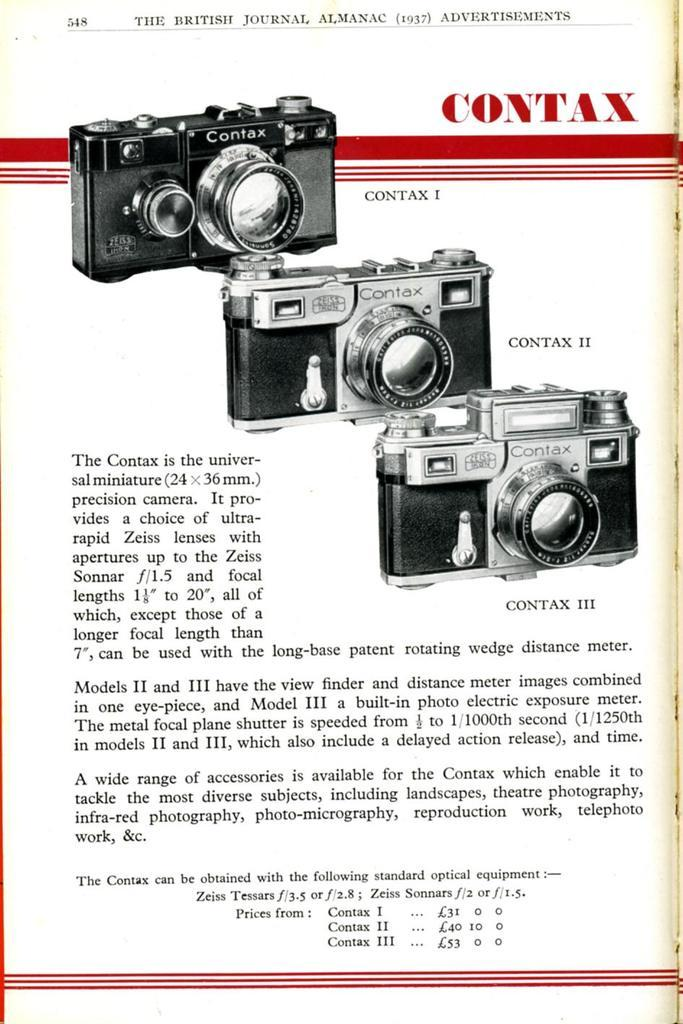<image>
Offer a succinct explanation of the picture presented. an old magazine add of a contax camera that shows different types of it 